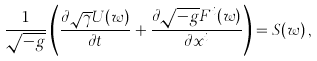<formula> <loc_0><loc_0><loc_500><loc_500>\frac { 1 } { \sqrt { - g } } \left ( \frac { \partial \sqrt { \gamma } { U } ( { w } ) } { \partial t } + \frac { \partial \sqrt { - g } { F } ^ { i } ( { w } ) } { \partial x ^ { i } } \right ) = { S } ( { w } ) \, ,</formula> 